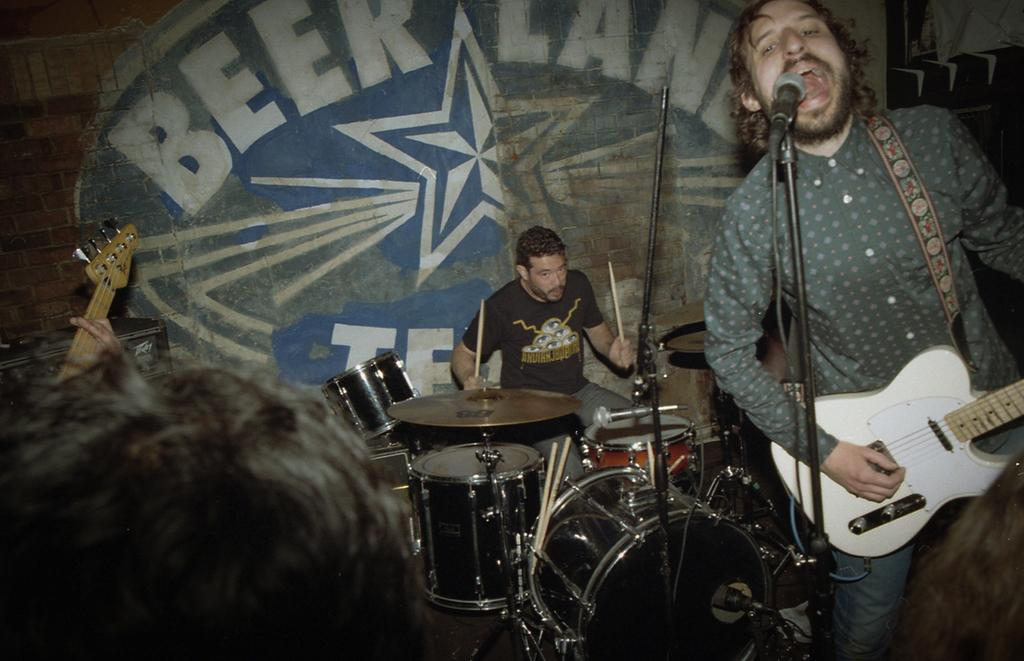What is the man in the image doing? The man is singing in the image. What is the man holding while singing? The man is holding a microphone. What instrument is the man playing? The man is playing a guitar. Are there any other musicians in the image? Yes, there is a man playing drums in the image. What can be seen in the background of the image? There is a wall in the background of the image. What shape is the baseball being thrown in the image? There is no baseball present in the image. What appliance is being used by the man playing drums? The provided facts do not mention any appliances being used by the drummer. 